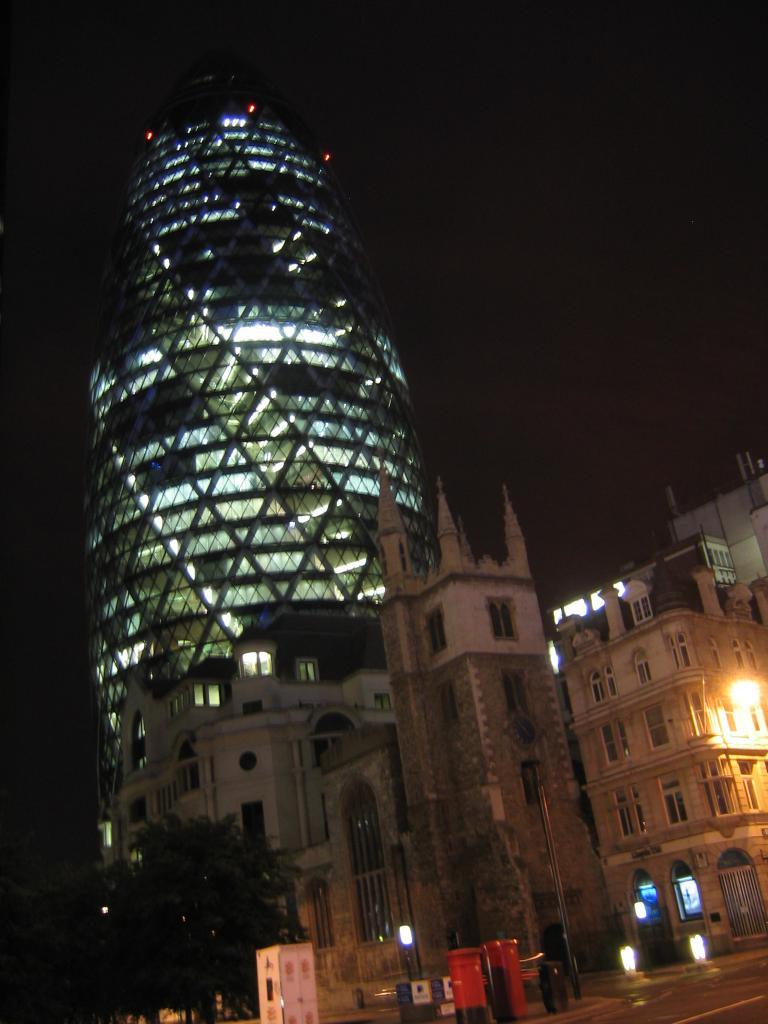What type of pathway is visible in the image? There is a road in the image. What object is present for mailing purposes? There is a post box in the image. What structure can be seen in the image for temporary shelter or service? There is a booth in the image. What type of illumination is present in the image? There are lights in the image. What type of vegetation is visible in the image? There are trees in the image. What type of structures have openings for light and ventilation in the image? There are buildings with windows in the image. How would you describe the overall lighting condition in the image? The background of the image is dark. What type of boundary is depicted in the image? There is no boundary depicted in the image. What direction are the trees facing in the image? The direction the trees are facing cannot be determined from the image. 